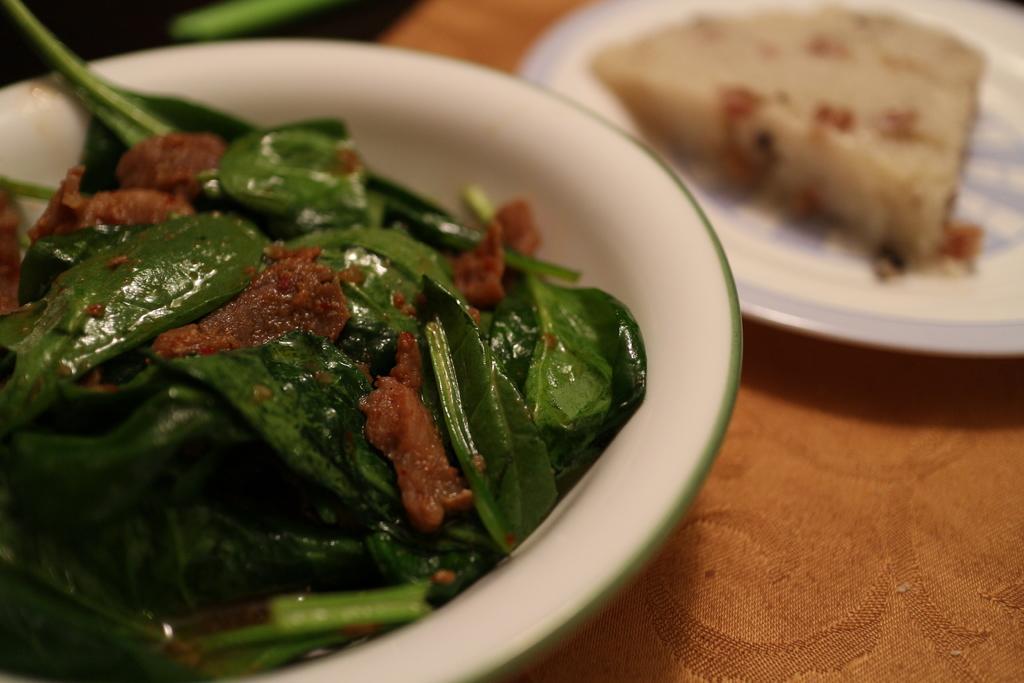Describe this image in one or two sentences. In this picture we can see food on a plate. We can see spinach leaves and food in a bowl. In the bottom right corner of the picture we can see a cloth. 